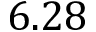<formula> <loc_0><loc_0><loc_500><loc_500>6 . 2 8</formula> 